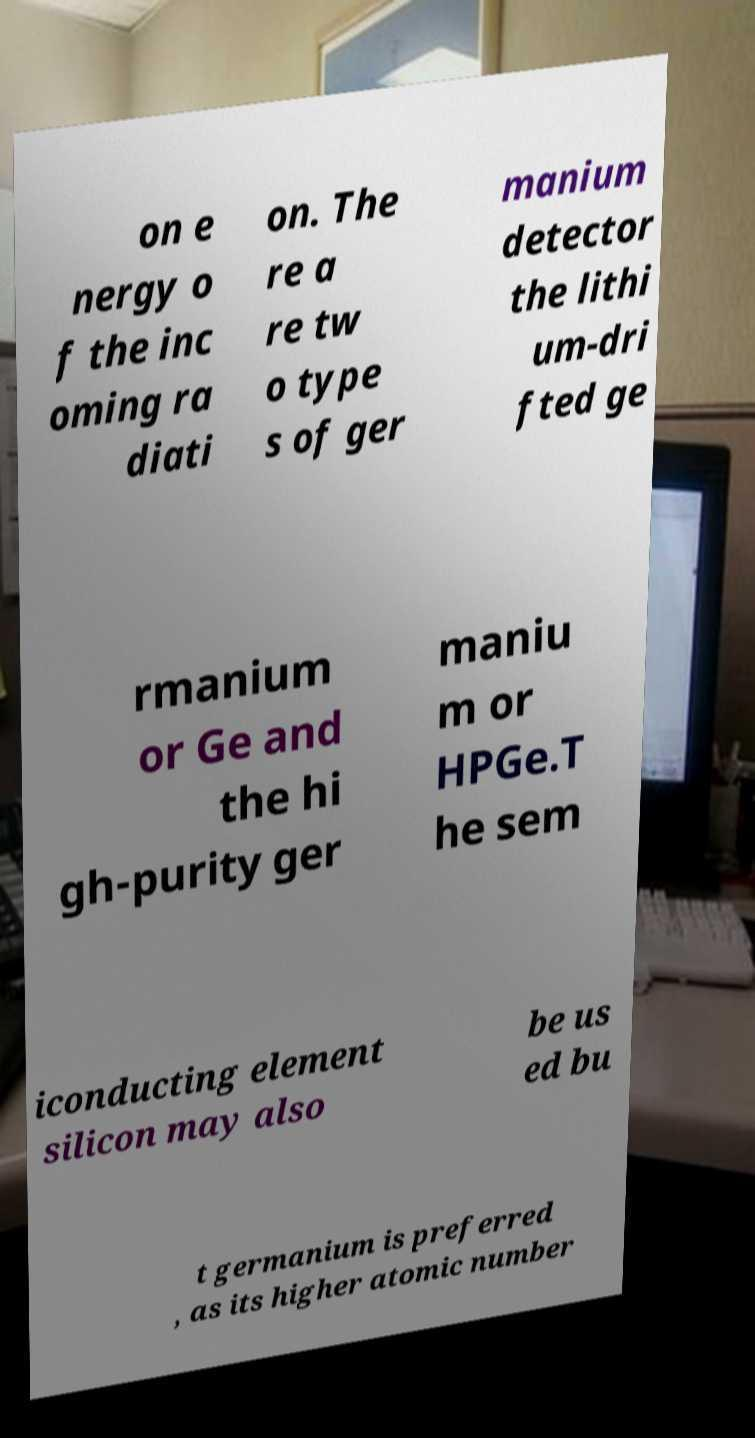Could you extract and type out the text from this image? on e nergy o f the inc oming ra diati on. The re a re tw o type s of ger manium detector the lithi um-dri fted ge rmanium or Ge and the hi gh-purity ger maniu m or HPGe.T he sem iconducting element silicon may also be us ed bu t germanium is preferred , as its higher atomic number 